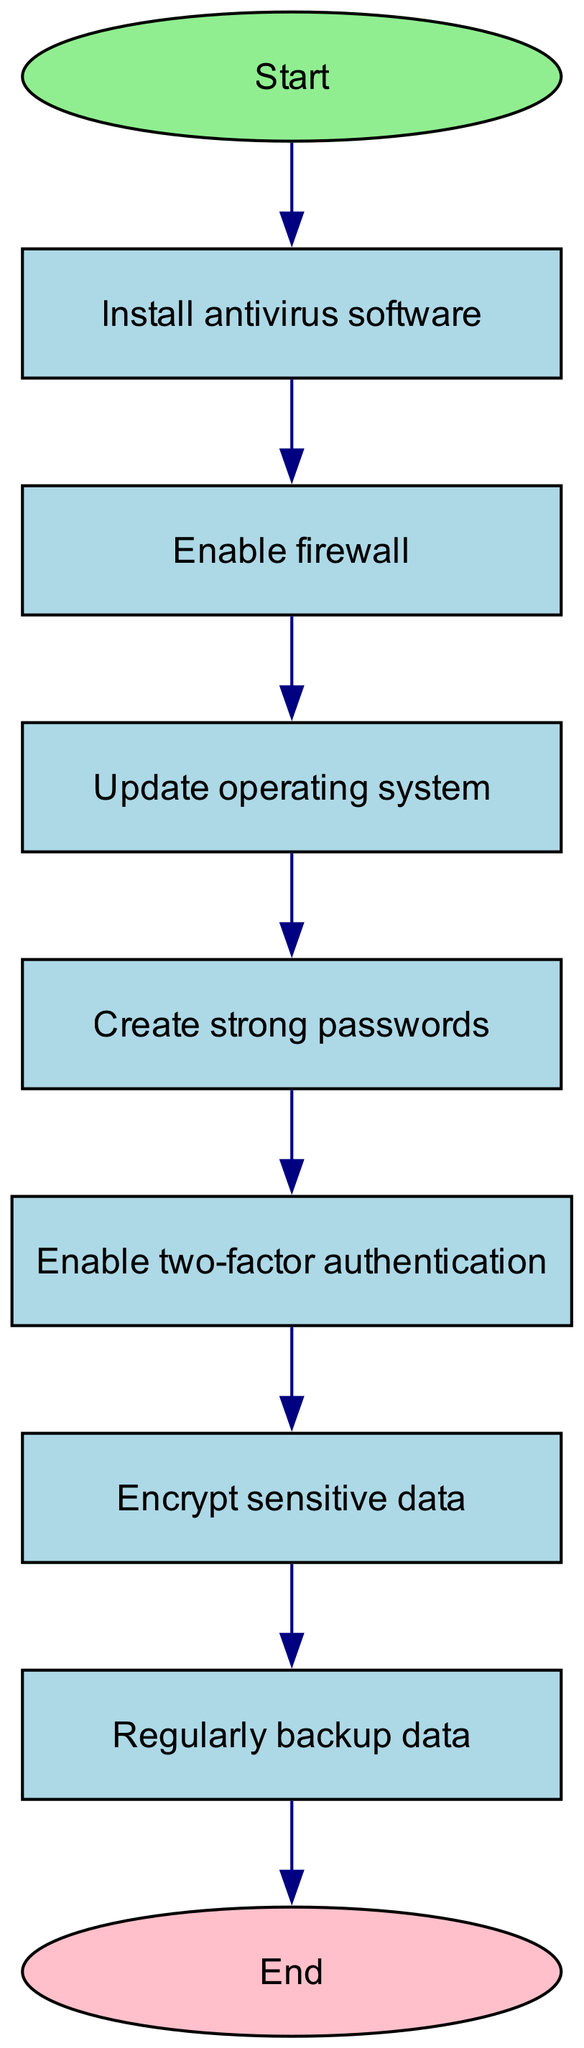What is the first step in securing a personal computer? The diagram starts from the node labeled "Start" which leads to "Install antivirus software", indicating that this is the first step in the process of securing a personal computer.
Answer: Install antivirus software How many steps are there in total to secure a personal computer? The diagram contains eight distinct steps from "Install antivirus software" to "Regularly backup data", not including the starting and ending nodes. Counting them gives a total of eight steps.
Answer: Eight What is the last step in the process? According to the diagram, the final step before reaching "End" is "Regularly backup data", indicating that this is the critical concluding action in securing the computer.
Answer: Regularly backup data Which node comes after enabling the firewall? In the flow of the diagram, after the node "Enable firewall", the next step is "Update operating system", illustrating the sequence of actions in the process.
Answer: Update operating system What comes before enabling two-factor authentication? The diagram shows that the node preceding "Enable two-factor authentication" is "Create strong passwords", indicating this as a necessary step before adding two-factor authentication.
Answer: Create strong passwords Is encrypting sensitive data required before backing up data? Yes, the diagram indicates that "Encrypt sensitive data" must be completed before moving on to "Regularly backup data", showing a dependency between these tasks.
Answer: Yes How many edges are there in the diagram connecting the nodes? The diagram contains eight edges connecting the nodes, each representing a directed transition from one step to the next in the process of securing a personal computer.
Answer: Eight Which step directly follows updating the operating system? The direct progression after "Update operating system" leads to the node for "Create strong passwords", confirming this as the next action in the sequence.
Answer: Create strong passwords 